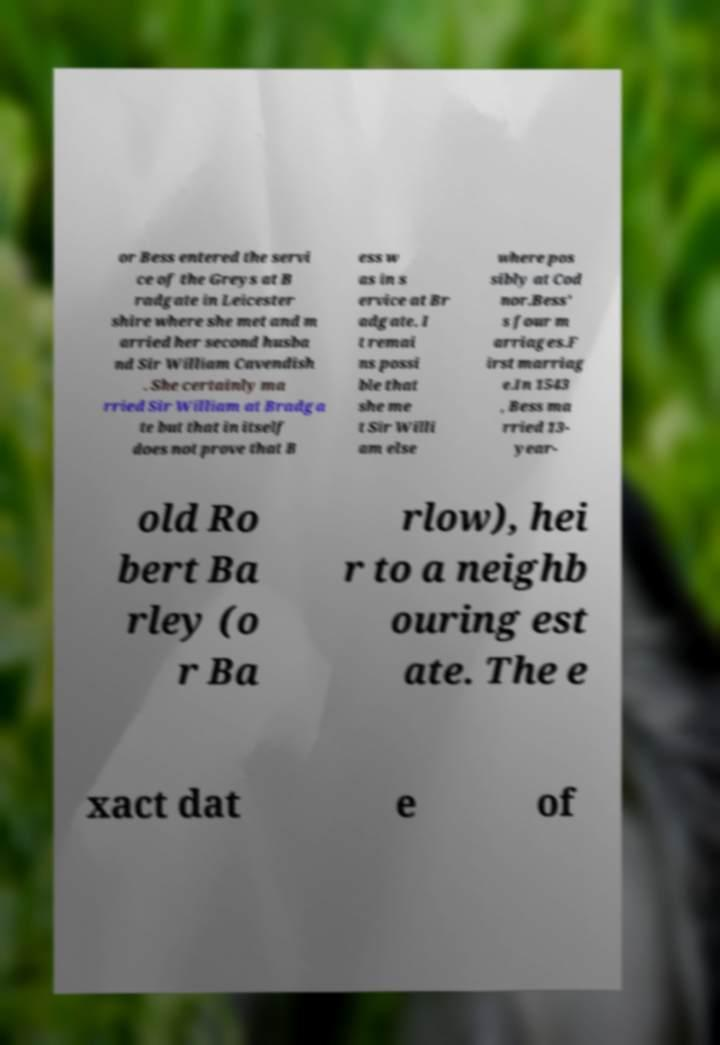Could you extract and type out the text from this image? or Bess entered the servi ce of the Greys at B radgate in Leicester shire where she met and m arried her second husba nd Sir William Cavendish . She certainly ma rried Sir William at Bradga te but that in itself does not prove that B ess w as in s ervice at Br adgate. I t remai ns possi ble that she me t Sir Willi am else where pos sibly at Cod nor.Bess' s four m arriages.F irst marriag e.In 1543 , Bess ma rried 13- year- old Ro bert Ba rley (o r Ba rlow), hei r to a neighb ouring est ate. The e xact dat e of 